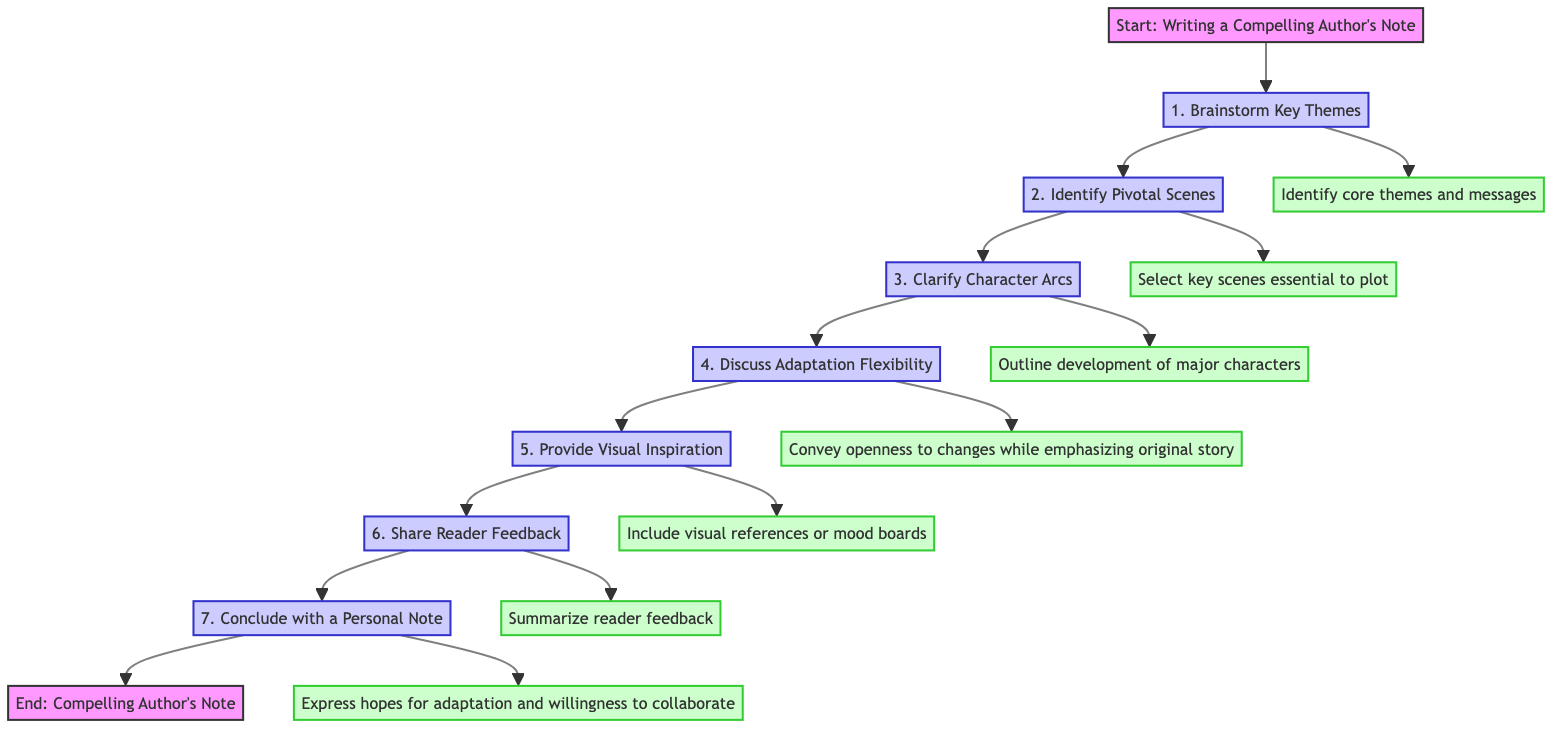What is the first step in writing an author's note? The flow chart indicates that the first step is "1. Brainstorm Key Themes," which initiates the process of creating a compelling author's note.
Answer: 1. Brainstorm Key Themes How many steps are there in the diagram? By counting the number of distinct steps listed in the flow chart, there are a total of seven steps that outline the process for writing an author's note.
Answer: 7 Which step emphasizes the importance of character development? The step labeled "3. Clarify Character Arcs" focuses on the development of major characters, underlining their significance in the narrative.
Answer: 3. Clarify Character Arcs What is the second-to-last step in the process? The flow chart shows that "6. Share Reader Feedback" is the second-to-last step before concluding the author's note.
Answer: 6. Share Reader Feedback Which step discusses flexibility in adaptation? "4. Discuss Adaptation Flexibility" conveys the author's openness to certain changes in the story while maintaining fidelity to the original plot.
Answer: 4. Discuss Adaptation Flexibility What type of references does the fifth step suggest including? The fifth step recommends including "visual references or mood boards," emphasizing the tone and setting of the book.
Answer: visual references or mood boards How does the process end? The diagram indicates that the process concludes with "End: Compelling Author's Note," which signifies the completion of the author's note writing.
Answer: End: Compelling Author's Note In which step is reader feedback summarized? The summary of reader feedback is found in "6. Share Reader Feedback," which highlights the reception of the book and its significance to the audience.
Answer: 6. Share Reader Feedback What is a non-negotiable component in the adaptation process? "2. Identify Pivotal Scenes" specifies that there are key scenes essential to the plot that must remain unchanged, making them non-negotiable for a faithful adaptation.
Answer: 2. Identify Pivotal Scenes 